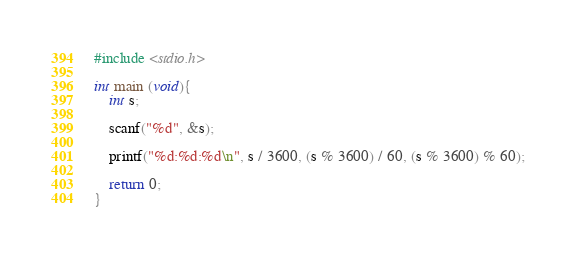Convert code to text. <code><loc_0><loc_0><loc_500><loc_500><_C_>#include <stdio.h>

int main (void){
    int s;
    
    scanf("%d", &s);
    
    printf("%d:%d:%d\n", s / 3600, (s % 3600) / 60, (s % 3600) % 60);
 
    return 0;
}</code> 